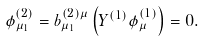Convert formula to latex. <formula><loc_0><loc_0><loc_500><loc_500>\phi ^ { ( 2 ) } _ { \mu _ { 1 } } = b ^ { ( 2 ) \mu } _ { \mu _ { 1 } } \left ( Y ^ { ( 1 ) } \phi ^ { ( 1 ) } _ { \mu } \right ) = 0 .</formula> 